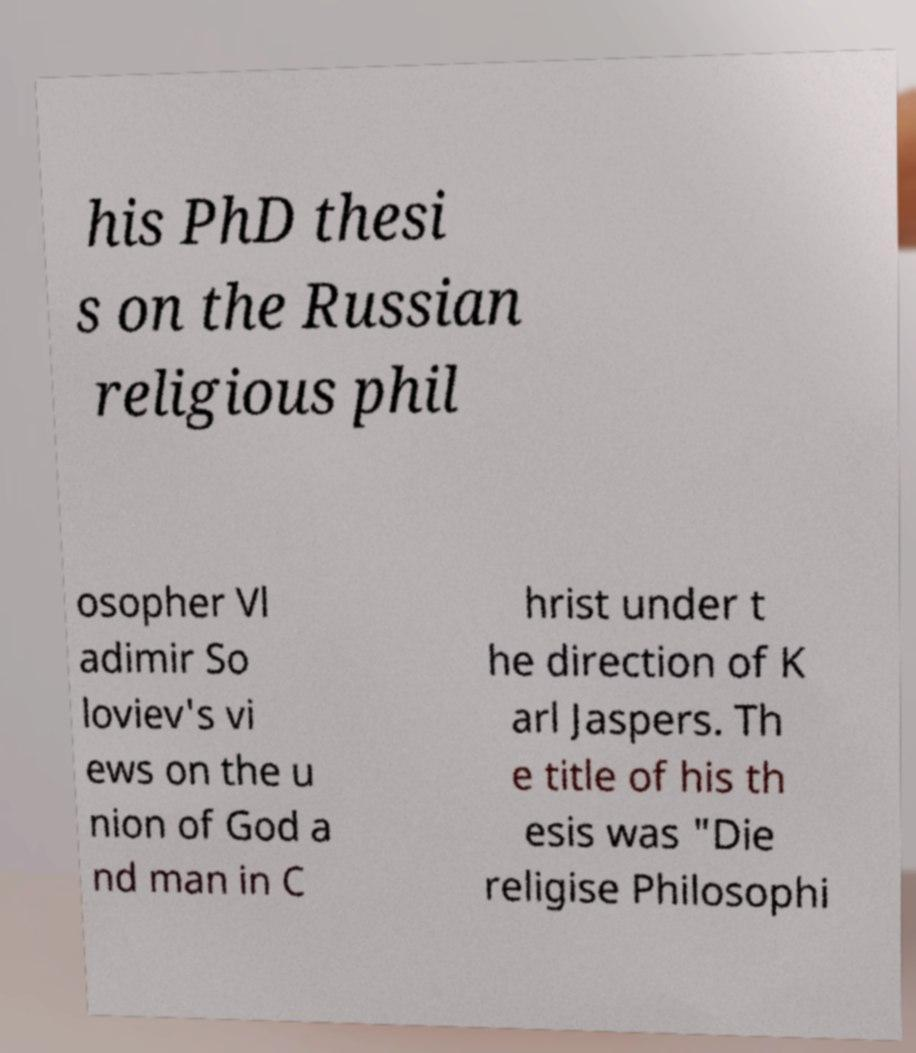Can you read and provide the text displayed in the image?This photo seems to have some interesting text. Can you extract and type it out for me? his PhD thesi s on the Russian religious phil osopher Vl adimir So loviev's vi ews on the u nion of God a nd man in C hrist under t he direction of K arl Jaspers. Th e title of his th esis was "Die religise Philosophi 